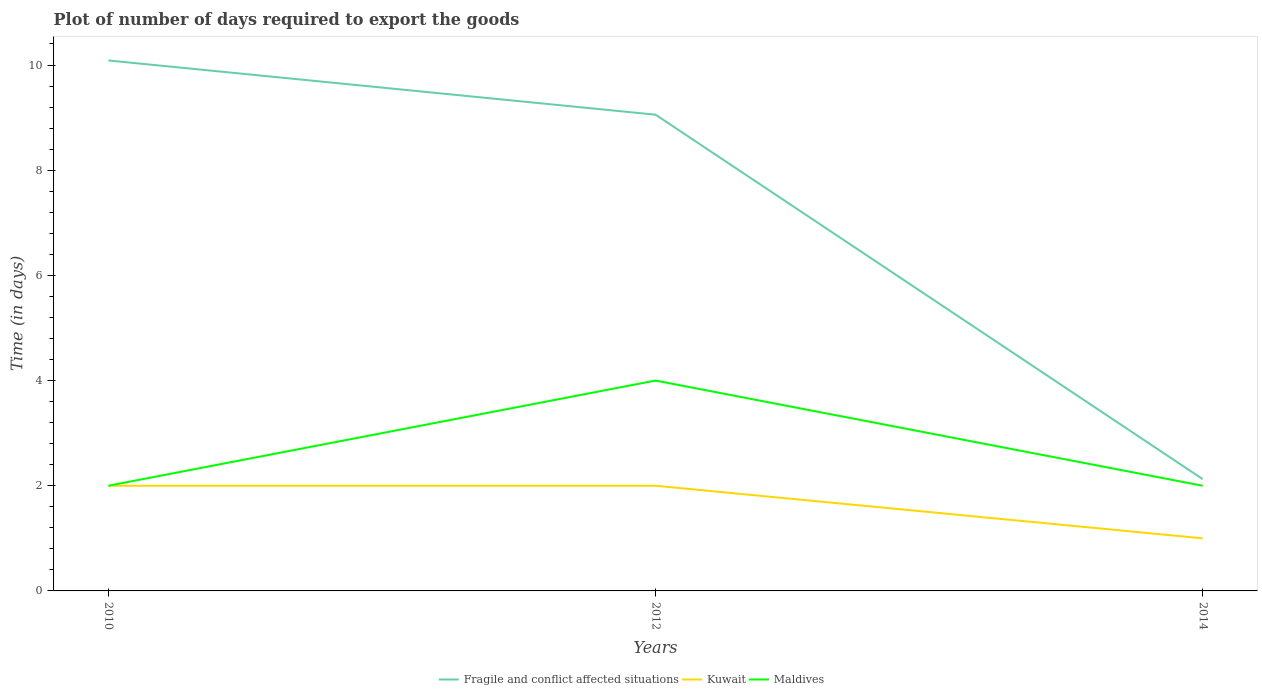Does the line corresponding to Kuwait intersect with the line corresponding to Fragile and conflict affected situations?
Offer a terse response. No. In which year was the time required to export goods in Maldives maximum?
Your response must be concise. 2010. What is the total time required to export goods in Kuwait in the graph?
Your answer should be very brief. 1. What is the difference between the highest and the second highest time required to export goods in Maldives?
Offer a very short reply. 2. Are the values on the major ticks of Y-axis written in scientific E-notation?
Offer a terse response. No. Does the graph contain any zero values?
Your answer should be compact. No. Does the graph contain grids?
Make the answer very short. No. How are the legend labels stacked?
Give a very brief answer. Horizontal. What is the title of the graph?
Your answer should be very brief. Plot of number of days required to export the goods. Does "Korea (Democratic)" appear as one of the legend labels in the graph?
Your answer should be very brief. No. What is the label or title of the X-axis?
Make the answer very short. Years. What is the label or title of the Y-axis?
Provide a succinct answer. Time (in days). What is the Time (in days) of Fragile and conflict affected situations in 2010?
Ensure brevity in your answer.  10.09. What is the Time (in days) of Kuwait in 2010?
Your answer should be very brief. 2. What is the Time (in days) of Maldives in 2010?
Keep it short and to the point. 2. What is the Time (in days) in Fragile and conflict affected situations in 2012?
Offer a very short reply. 9.06. What is the Time (in days) in Kuwait in 2012?
Offer a very short reply. 2. What is the Time (in days) in Maldives in 2012?
Keep it short and to the point. 4. What is the Time (in days) in Fragile and conflict affected situations in 2014?
Your answer should be very brief. 2.12. What is the Time (in days) of Maldives in 2014?
Your answer should be compact. 2. Across all years, what is the maximum Time (in days) of Fragile and conflict affected situations?
Your response must be concise. 10.09. Across all years, what is the minimum Time (in days) in Fragile and conflict affected situations?
Your answer should be very brief. 2.12. Across all years, what is the minimum Time (in days) in Kuwait?
Your response must be concise. 1. What is the total Time (in days) of Fragile and conflict affected situations in the graph?
Offer a terse response. 21.27. What is the total Time (in days) in Kuwait in the graph?
Make the answer very short. 5. What is the difference between the Time (in days) in Fragile and conflict affected situations in 2010 and that in 2012?
Offer a very short reply. 1.03. What is the difference between the Time (in days) of Kuwait in 2010 and that in 2012?
Make the answer very short. 0. What is the difference between the Time (in days) in Fragile and conflict affected situations in 2010 and that in 2014?
Your answer should be very brief. 7.96. What is the difference between the Time (in days) of Kuwait in 2010 and that in 2014?
Your answer should be compact. 1. What is the difference between the Time (in days) in Fragile and conflict affected situations in 2012 and that in 2014?
Provide a short and direct response. 6.93. What is the difference between the Time (in days) in Fragile and conflict affected situations in 2010 and the Time (in days) in Kuwait in 2012?
Give a very brief answer. 8.09. What is the difference between the Time (in days) of Fragile and conflict affected situations in 2010 and the Time (in days) of Maldives in 2012?
Your answer should be compact. 6.09. What is the difference between the Time (in days) of Kuwait in 2010 and the Time (in days) of Maldives in 2012?
Your response must be concise. -2. What is the difference between the Time (in days) in Fragile and conflict affected situations in 2010 and the Time (in days) in Kuwait in 2014?
Ensure brevity in your answer.  9.09. What is the difference between the Time (in days) in Fragile and conflict affected situations in 2010 and the Time (in days) in Maldives in 2014?
Keep it short and to the point. 8.09. What is the difference between the Time (in days) of Kuwait in 2010 and the Time (in days) of Maldives in 2014?
Give a very brief answer. 0. What is the difference between the Time (in days) of Fragile and conflict affected situations in 2012 and the Time (in days) of Kuwait in 2014?
Your answer should be very brief. 8.06. What is the difference between the Time (in days) in Fragile and conflict affected situations in 2012 and the Time (in days) in Maldives in 2014?
Offer a terse response. 7.06. What is the average Time (in days) in Fragile and conflict affected situations per year?
Provide a succinct answer. 7.09. What is the average Time (in days) in Kuwait per year?
Ensure brevity in your answer.  1.67. What is the average Time (in days) in Maldives per year?
Keep it short and to the point. 2.67. In the year 2010, what is the difference between the Time (in days) of Fragile and conflict affected situations and Time (in days) of Kuwait?
Provide a succinct answer. 8.09. In the year 2010, what is the difference between the Time (in days) of Fragile and conflict affected situations and Time (in days) of Maldives?
Your response must be concise. 8.09. In the year 2012, what is the difference between the Time (in days) of Fragile and conflict affected situations and Time (in days) of Kuwait?
Your answer should be very brief. 7.06. In the year 2012, what is the difference between the Time (in days) in Fragile and conflict affected situations and Time (in days) in Maldives?
Keep it short and to the point. 5.06. In the year 2014, what is the difference between the Time (in days) of Kuwait and Time (in days) of Maldives?
Your answer should be compact. -1. What is the ratio of the Time (in days) in Fragile and conflict affected situations in 2010 to that in 2012?
Your response must be concise. 1.11. What is the ratio of the Time (in days) of Kuwait in 2010 to that in 2012?
Offer a terse response. 1. What is the ratio of the Time (in days) in Maldives in 2010 to that in 2012?
Offer a terse response. 0.5. What is the ratio of the Time (in days) of Fragile and conflict affected situations in 2010 to that in 2014?
Offer a terse response. 4.75. What is the ratio of the Time (in days) in Maldives in 2010 to that in 2014?
Your answer should be compact. 1. What is the ratio of the Time (in days) in Fragile and conflict affected situations in 2012 to that in 2014?
Provide a short and direct response. 4.26. What is the ratio of the Time (in days) in Kuwait in 2012 to that in 2014?
Your answer should be very brief. 2. What is the ratio of the Time (in days) in Maldives in 2012 to that in 2014?
Offer a very short reply. 2. What is the difference between the highest and the second highest Time (in days) in Fragile and conflict affected situations?
Make the answer very short. 1.03. What is the difference between the highest and the second highest Time (in days) of Kuwait?
Give a very brief answer. 0. What is the difference between the highest and the second highest Time (in days) in Maldives?
Offer a very short reply. 2. What is the difference between the highest and the lowest Time (in days) of Fragile and conflict affected situations?
Offer a terse response. 7.96. What is the difference between the highest and the lowest Time (in days) in Kuwait?
Make the answer very short. 1. What is the difference between the highest and the lowest Time (in days) in Maldives?
Ensure brevity in your answer.  2. 